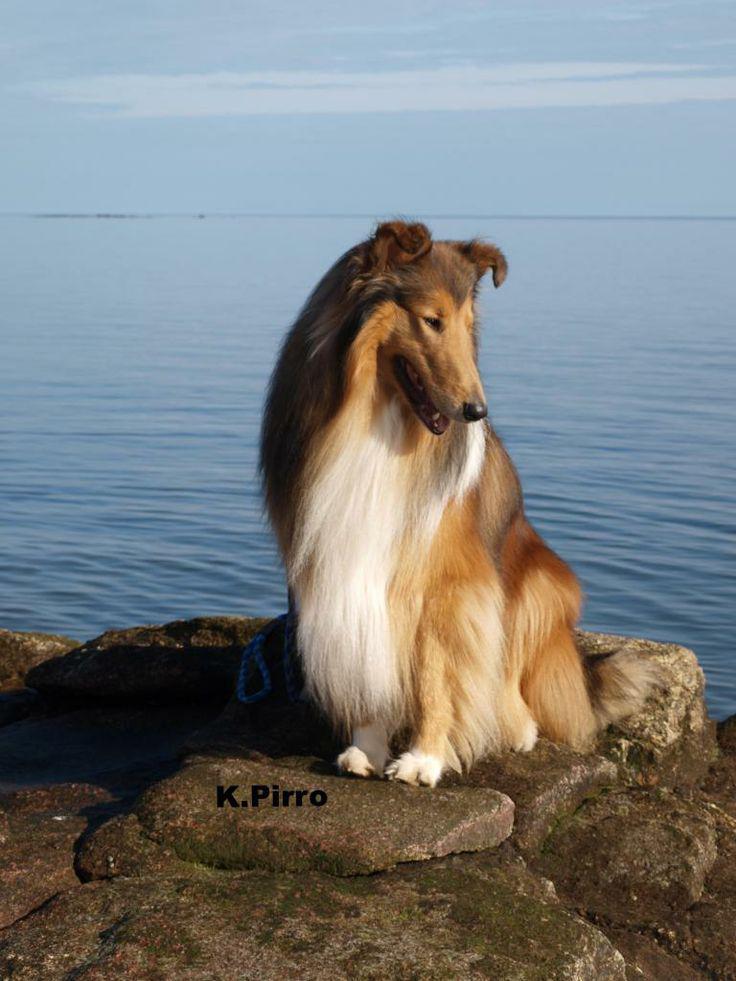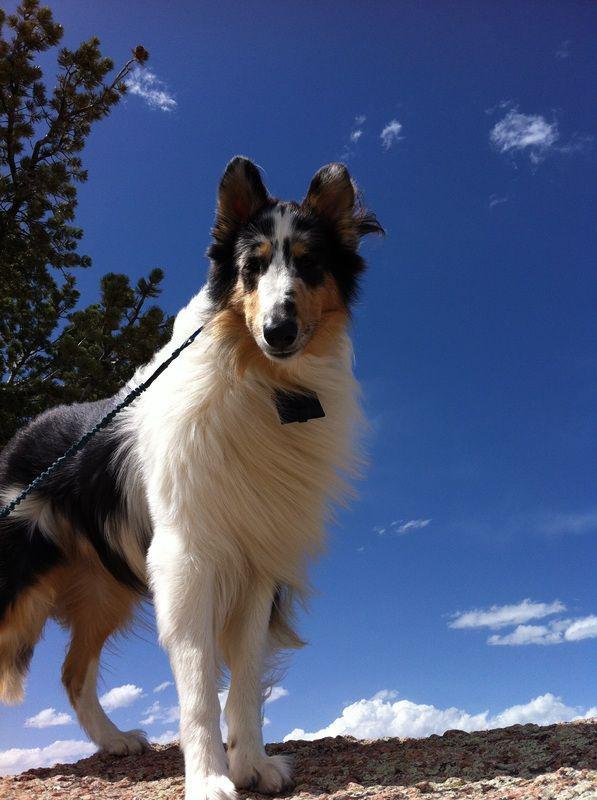The first image is the image on the left, the second image is the image on the right. For the images shown, is this caption "a body of water is visible behind a dog" true? Answer yes or no. Yes. The first image is the image on the left, the second image is the image on the right. For the images displayed, is the sentence "Exactly one dog is sitting." factually correct? Answer yes or no. Yes. 